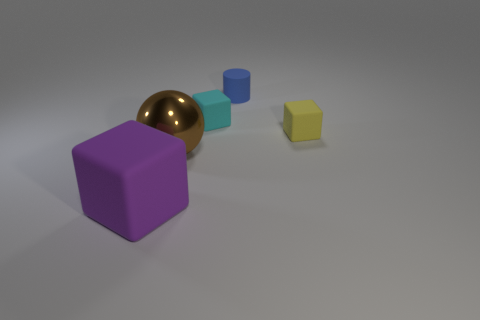There is a yellow thing that is the same shape as the small cyan object; what size is it? The yellow object, which has a cubic shape similar to the small cyan one, is also small in size. 